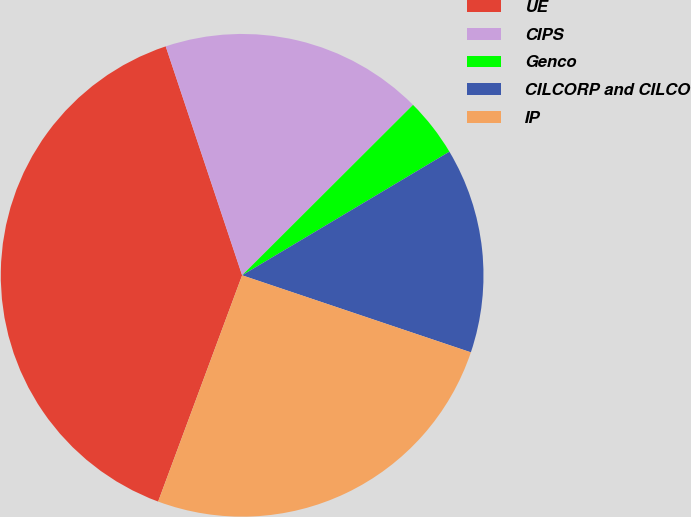Convert chart to OTSL. <chart><loc_0><loc_0><loc_500><loc_500><pie_chart><fcel>UE<fcel>CIPS<fcel>Genco<fcel>CILCORP and CILCO<fcel>IP<nl><fcel>39.22%<fcel>17.65%<fcel>3.92%<fcel>13.73%<fcel>25.49%<nl></chart> 